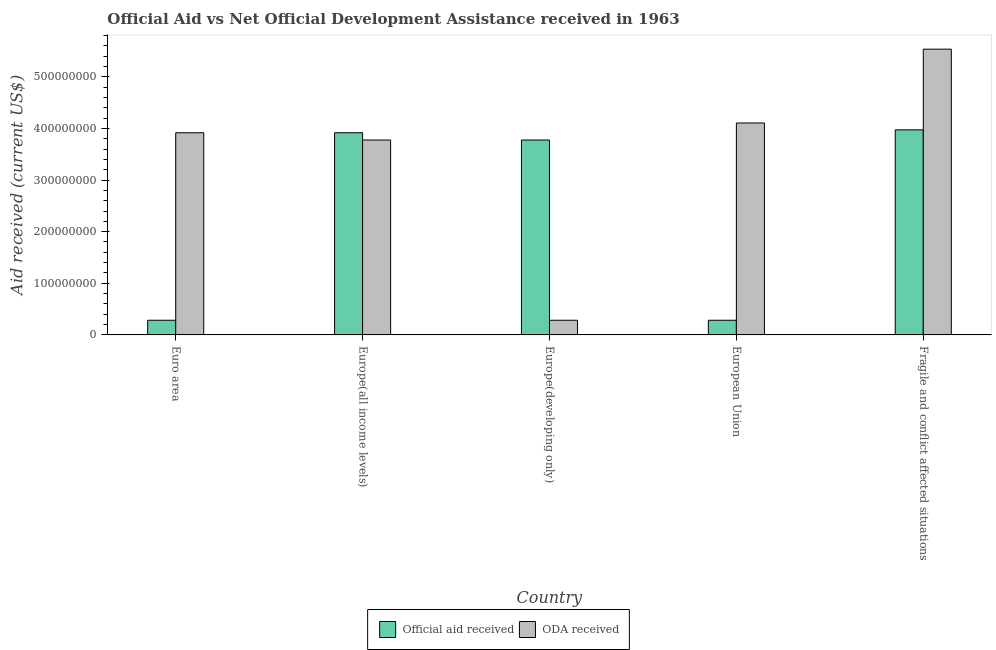How many different coloured bars are there?
Your answer should be compact. 2. How many groups of bars are there?
Your answer should be compact. 5. Are the number of bars per tick equal to the number of legend labels?
Your response must be concise. Yes. How many bars are there on the 3rd tick from the left?
Your answer should be very brief. 2. How many bars are there on the 2nd tick from the right?
Make the answer very short. 2. What is the label of the 5th group of bars from the left?
Provide a short and direct response. Fragile and conflict affected situations. What is the oda received in Europe(all income levels)?
Your answer should be compact. 3.78e+08. Across all countries, what is the maximum oda received?
Keep it short and to the point. 5.54e+08. Across all countries, what is the minimum oda received?
Keep it short and to the point. 2.84e+07. In which country was the oda received maximum?
Your answer should be very brief. Fragile and conflict affected situations. What is the total oda received in the graph?
Keep it short and to the point. 1.76e+09. What is the difference between the official aid received in Euro area and that in European Union?
Your answer should be very brief. 0. What is the difference between the official aid received in European Union and the oda received in Fragile and conflict affected situations?
Your answer should be compact. -5.25e+08. What is the average official aid received per country?
Ensure brevity in your answer.  2.45e+08. What is the difference between the official aid received and oda received in Europe(all income levels)?
Provide a short and direct response. 1.40e+07. What is the ratio of the official aid received in European Union to that in Fragile and conflict affected situations?
Provide a succinct answer. 0.07. Is the official aid received in Europe(developing only) less than that in European Union?
Give a very brief answer. No. Is the difference between the official aid received in Euro area and Europe(developing only) greater than the difference between the oda received in Euro area and Europe(developing only)?
Your response must be concise. No. What is the difference between the highest and the second highest oda received?
Make the answer very short. 1.43e+08. What is the difference between the highest and the lowest official aid received?
Offer a terse response. 3.69e+08. What does the 1st bar from the left in Euro area represents?
Your response must be concise. Official aid received. What does the 1st bar from the right in Euro area represents?
Offer a terse response. ODA received. How many bars are there?
Provide a short and direct response. 10. Are all the bars in the graph horizontal?
Offer a very short reply. No. How many countries are there in the graph?
Give a very brief answer. 5. Does the graph contain grids?
Offer a very short reply. No. Where does the legend appear in the graph?
Provide a succinct answer. Bottom center. How are the legend labels stacked?
Your answer should be very brief. Horizontal. What is the title of the graph?
Keep it short and to the point. Official Aid vs Net Official Development Assistance received in 1963 . What is the label or title of the X-axis?
Provide a succinct answer. Country. What is the label or title of the Y-axis?
Provide a succinct answer. Aid received (current US$). What is the Aid received (current US$) in Official aid received in Euro area?
Your response must be concise. 2.84e+07. What is the Aid received (current US$) in ODA received in Euro area?
Offer a very short reply. 3.92e+08. What is the Aid received (current US$) in Official aid received in Europe(all income levels)?
Your answer should be compact. 3.92e+08. What is the Aid received (current US$) of ODA received in Europe(all income levels)?
Provide a succinct answer. 3.78e+08. What is the Aid received (current US$) of Official aid received in Europe(developing only)?
Keep it short and to the point. 3.78e+08. What is the Aid received (current US$) in ODA received in Europe(developing only)?
Make the answer very short. 2.84e+07. What is the Aid received (current US$) in Official aid received in European Union?
Make the answer very short. 2.84e+07. What is the Aid received (current US$) in ODA received in European Union?
Provide a short and direct response. 4.11e+08. What is the Aid received (current US$) of Official aid received in Fragile and conflict affected situations?
Provide a succinct answer. 3.97e+08. What is the Aid received (current US$) in ODA received in Fragile and conflict affected situations?
Your answer should be compact. 5.54e+08. Across all countries, what is the maximum Aid received (current US$) in Official aid received?
Make the answer very short. 3.97e+08. Across all countries, what is the maximum Aid received (current US$) in ODA received?
Give a very brief answer. 5.54e+08. Across all countries, what is the minimum Aid received (current US$) in Official aid received?
Keep it short and to the point. 2.84e+07. Across all countries, what is the minimum Aid received (current US$) in ODA received?
Your response must be concise. 2.84e+07. What is the total Aid received (current US$) in Official aid received in the graph?
Provide a succinct answer. 1.22e+09. What is the total Aid received (current US$) of ODA received in the graph?
Offer a terse response. 1.76e+09. What is the difference between the Aid received (current US$) of Official aid received in Euro area and that in Europe(all income levels)?
Your response must be concise. -3.63e+08. What is the difference between the Aid received (current US$) of ODA received in Euro area and that in Europe(all income levels)?
Your answer should be compact. 1.40e+07. What is the difference between the Aid received (current US$) in Official aid received in Euro area and that in Europe(developing only)?
Offer a terse response. -3.49e+08. What is the difference between the Aid received (current US$) in ODA received in Euro area and that in Europe(developing only)?
Provide a short and direct response. 3.63e+08. What is the difference between the Aid received (current US$) in ODA received in Euro area and that in European Union?
Give a very brief answer. -1.89e+07. What is the difference between the Aid received (current US$) in Official aid received in Euro area and that in Fragile and conflict affected situations?
Keep it short and to the point. -3.69e+08. What is the difference between the Aid received (current US$) in ODA received in Euro area and that in Fragile and conflict affected situations?
Offer a terse response. -1.62e+08. What is the difference between the Aid received (current US$) of Official aid received in Europe(all income levels) and that in Europe(developing only)?
Offer a terse response. 1.40e+07. What is the difference between the Aid received (current US$) of ODA received in Europe(all income levels) and that in Europe(developing only)?
Make the answer very short. 3.49e+08. What is the difference between the Aid received (current US$) in Official aid received in Europe(all income levels) and that in European Union?
Keep it short and to the point. 3.63e+08. What is the difference between the Aid received (current US$) in ODA received in Europe(all income levels) and that in European Union?
Your answer should be very brief. -3.30e+07. What is the difference between the Aid received (current US$) of Official aid received in Europe(all income levels) and that in Fragile and conflict affected situations?
Your response must be concise. -5.61e+06. What is the difference between the Aid received (current US$) in ODA received in Europe(all income levels) and that in Fragile and conflict affected situations?
Provide a succinct answer. -1.76e+08. What is the difference between the Aid received (current US$) in Official aid received in Europe(developing only) and that in European Union?
Provide a short and direct response. 3.49e+08. What is the difference between the Aid received (current US$) in ODA received in Europe(developing only) and that in European Union?
Your response must be concise. -3.82e+08. What is the difference between the Aid received (current US$) in Official aid received in Europe(developing only) and that in Fragile and conflict affected situations?
Your answer should be very brief. -1.97e+07. What is the difference between the Aid received (current US$) in ODA received in Europe(developing only) and that in Fragile and conflict affected situations?
Give a very brief answer. -5.25e+08. What is the difference between the Aid received (current US$) in Official aid received in European Union and that in Fragile and conflict affected situations?
Offer a terse response. -3.69e+08. What is the difference between the Aid received (current US$) of ODA received in European Union and that in Fragile and conflict affected situations?
Ensure brevity in your answer.  -1.43e+08. What is the difference between the Aid received (current US$) of Official aid received in Euro area and the Aid received (current US$) of ODA received in Europe(all income levels)?
Your answer should be very brief. -3.49e+08. What is the difference between the Aid received (current US$) of Official aid received in Euro area and the Aid received (current US$) of ODA received in European Union?
Your answer should be very brief. -3.82e+08. What is the difference between the Aid received (current US$) of Official aid received in Euro area and the Aid received (current US$) of ODA received in Fragile and conflict affected situations?
Offer a terse response. -5.25e+08. What is the difference between the Aid received (current US$) of Official aid received in Europe(all income levels) and the Aid received (current US$) of ODA received in Europe(developing only)?
Give a very brief answer. 3.63e+08. What is the difference between the Aid received (current US$) in Official aid received in Europe(all income levels) and the Aid received (current US$) in ODA received in European Union?
Your response must be concise. -1.89e+07. What is the difference between the Aid received (current US$) of Official aid received in Europe(all income levels) and the Aid received (current US$) of ODA received in Fragile and conflict affected situations?
Provide a short and direct response. -1.62e+08. What is the difference between the Aid received (current US$) of Official aid received in Europe(developing only) and the Aid received (current US$) of ODA received in European Union?
Your answer should be compact. -3.30e+07. What is the difference between the Aid received (current US$) of Official aid received in Europe(developing only) and the Aid received (current US$) of ODA received in Fragile and conflict affected situations?
Your answer should be very brief. -1.76e+08. What is the difference between the Aid received (current US$) in Official aid received in European Union and the Aid received (current US$) in ODA received in Fragile and conflict affected situations?
Offer a very short reply. -5.25e+08. What is the average Aid received (current US$) of Official aid received per country?
Your response must be concise. 2.45e+08. What is the average Aid received (current US$) in ODA received per country?
Give a very brief answer. 3.52e+08. What is the difference between the Aid received (current US$) in Official aid received and Aid received (current US$) in ODA received in Euro area?
Give a very brief answer. -3.63e+08. What is the difference between the Aid received (current US$) of Official aid received and Aid received (current US$) of ODA received in Europe(all income levels)?
Provide a short and direct response. 1.40e+07. What is the difference between the Aid received (current US$) of Official aid received and Aid received (current US$) of ODA received in Europe(developing only)?
Make the answer very short. 3.49e+08. What is the difference between the Aid received (current US$) of Official aid received and Aid received (current US$) of ODA received in European Union?
Provide a short and direct response. -3.82e+08. What is the difference between the Aid received (current US$) in Official aid received and Aid received (current US$) in ODA received in Fragile and conflict affected situations?
Make the answer very short. -1.56e+08. What is the ratio of the Aid received (current US$) in Official aid received in Euro area to that in Europe(all income levels)?
Make the answer very short. 0.07. What is the ratio of the Aid received (current US$) of ODA received in Euro area to that in Europe(all income levels)?
Your answer should be very brief. 1.04. What is the ratio of the Aid received (current US$) in Official aid received in Euro area to that in Europe(developing only)?
Keep it short and to the point. 0.08. What is the ratio of the Aid received (current US$) in ODA received in Euro area to that in Europe(developing only)?
Provide a succinct answer. 13.79. What is the ratio of the Aid received (current US$) of ODA received in Euro area to that in European Union?
Offer a very short reply. 0.95. What is the ratio of the Aid received (current US$) of Official aid received in Euro area to that in Fragile and conflict affected situations?
Ensure brevity in your answer.  0.07. What is the ratio of the Aid received (current US$) of ODA received in Euro area to that in Fragile and conflict affected situations?
Your answer should be very brief. 0.71. What is the ratio of the Aid received (current US$) of Official aid received in Europe(all income levels) to that in Europe(developing only)?
Give a very brief answer. 1.04. What is the ratio of the Aid received (current US$) of ODA received in Europe(all income levels) to that in Europe(developing only)?
Offer a very short reply. 13.3. What is the ratio of the Aid received (current US$) in Official aid received in Europe(all income levels) to that in European Union?
Make the answer very short. 13.79. What is the ratio of the Aid received (current US$) of ODA received in Europe(all income levels) to that in European Union?
Give a very brief answer. 0.92. What is the ratio of the Aid received (current US$) of Official aid received in Europe(all income levels) to that in Fragile and conflict affected situations?
Give a very brief answer. 0.99. What is the ratio of the Aid received (current US$) in ODA received in Europe(all income levels) to that in Fragile and conflict affected situations?
Your answer should be very brief. 0.68. What is the ratio of the Aid received (current US$) in Official aid received in Europe(developing only) to that in European Union?
Offer a very short reply. 13.3. What is the ratio of the Aid received (current US$) in ODA received in Europe(developing only) to that in European Union?
Offer a terse response. 0.07. What is the ratio of the Aid received (current US$) of Official aid received in Europe(developing only) to that in Fragile and conflict affected situations?
Give a very brief answer. 0.95. What is the ratio of the Aid received (current US$) in ODA received in Europe(developing only) to that in Fragile and conflict affected situations?
Your answer should be compact. 0.05. What is the ratio of the Aid received (current US$) of Official aid received in European Union to that in Fragile and conflict affected situations?
Make the answer very short. 0.07. What is the ratio of the Aid received (current US$) in ODA received in European Union to that in Fragile and conflict affected situations?
Make the answer very short. 0.74. What is the difference between the highest and the second highest Aid received (current US$) of Official aid received?
Give a very brief answer. 5.61e+06. What is the difference between the highest and the second highest Aid received (current US$) in ODA received?
Your answer should be very brief. 1.43e+08. What is the difference between the highest and the lowest Aid received (current US$) of Official aid received?
Keep it short and to the point. 3.69e+08. What is the difference between the highest and the lowest Aid received (current US$) in ODA received?
Keep it short and to the point. 5.25e+08. 